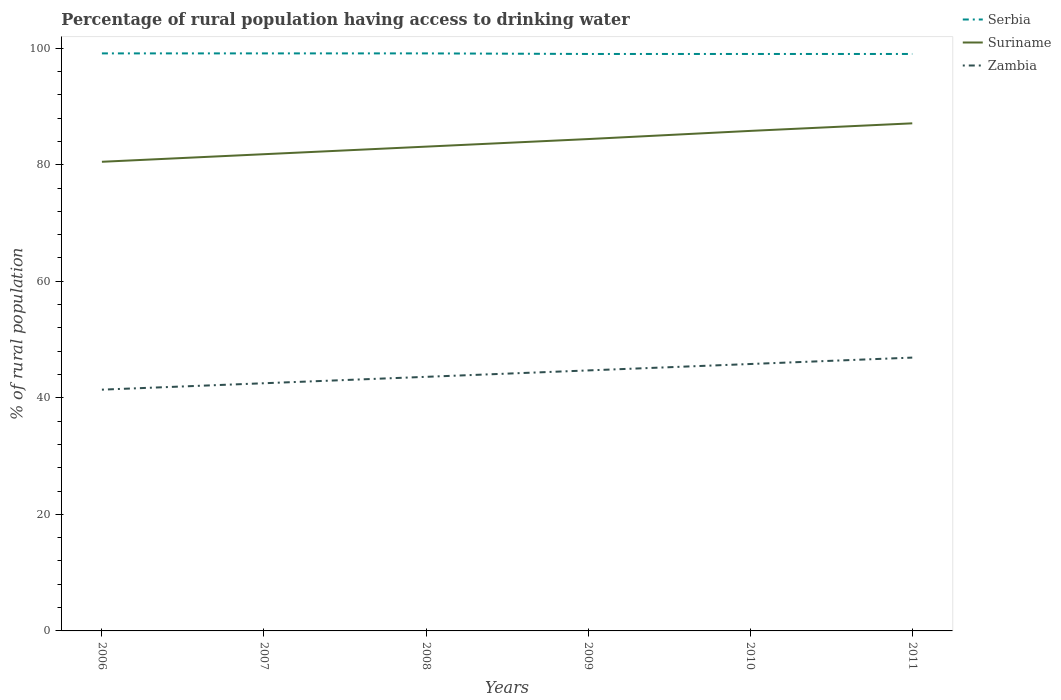Does the line corresponding to Zambia intersect with the line corresponding to Serbia?
Provide a short and direct response. No. Across all years, what is the maximum percentage of rural population having access to drinking water in Serbia?
Provide a succinct answer. 99. What is the total percentage of rural population having access to drinking water in Serbia in the graph?
Provide a succinct answer. 0.1. What is the difference between the highest and the second highest percentage of rural population having access to drinking water in Serbia?
Your response must be concise. 0.1. Is the percentage of rural population having access to drinking water in Zambia strictly greater than the percentage of rural population having access to drinking water in Suriname over the years?
Make the answer very short. Yes. How many lines are there?
Provide a short and direct response. 3. How many years are there in the graph?
Offer a very short reply. 6. Does the graph contain any zero values?
Ensure brevity in your answer.  No. Does the graph contain grids?
Provide a short and direct response. No. How many legend labels are there?
Ensure brevity in your answer.  3. What is the title of the graph?
Ensure brevity in your answer.  Percentage of rural population having access to drinking water. What is the label or title of the X-axis?
Keep it short and to the point. Years. What is the label or title of the Y-axis?
Provide a short and direct response. % of rural population. What is the % of rural population of Serbia in 2006?
Offer a terse response. 99.1. What is the % of rural population in Suriname in 2006?
Keep it short and to the point. 80.5. What is the % of rural population of Zambia in 2006?
Give a very brief answer. 41.4. What is the % of rural population of Serbia in 2007?
Make the answer very short. 99.1. What is the % of rural population of Suriname in 2007?
Offer a very short reply. 81.8. What is the % of rural population of Zambia in 2007?
Your response must be concise. 42.5. What is the % of rural population of Serbia in 2008?
Keep it short and to the point. 99.1. What is the % of rural population in Suriname in 2008?
Keep it short and to the point. 83.1. What is the % of rural population of Zambia in 2008?
Your response must be concise. 43.6. What is the % of rural population in Suriname in 2009?
Your answer should be very brief. 84.4. What is the % of rural population in Zambia in 2009?
Your answer should be very brief. 44.7. What is the % of rural population of Suriname in 2010?
Provide a succinct answer. 85.8. What is the % of rural population in Zambia in 2010?
Offer a very short reply. 45.8. What is the % of rural population of Suriname in 2011?
Your answer should be compact. 87.1. What is the % of rural population of Zambia in 2011?
Keep it short and to the point. 46.9. Across all years, what is the maximum % of rural population in Serbia?
Give a very brief answer. 99.1. Across all years, what is the maximum % of rural population in Suriname?
Your answer should be compact. 87.1. Across all years, what is the maximum % of rural population in Zambia?
Offer a terse response. 46.9. Across all years, what is the minimum % of rural population of Serbia?
Make the answer very short. 99. Across all years, what is the minimum % of rural population in Suriname?
Your answer should be compact. 80.5. Across all years, what is the minimum % of rural population in Zambia?
Your answer should be compact. 41.4. What is the total % of rural population of Serbia in the graph?
Ensure brevity in your answer.  594.3. What is the total % of rural population of Suriname in the graph?
Provide a succinct answer. 502.7. What is the total % of rural population of Zambia in the graph?
Ensure brevity in your answer.  264.9. What is the difference between the % of rural population in Serbia in 2006 and that in 2007?
Offer a very short reply. 0. What is the difference between the % of rural population in Suriname in 2006 and that in 2007?
Provide a succinct answer. -1.3. What is the difference between the % of rural population in Suriname in 2006 and that in 2008?
Provide a succinct answer. -2.6. What is the difference between the % of rural population of Zambia in 2006 and that in 2008?
Give a very brief answer. -2.2. What is the difference between the % of rural population of Suriname in 2006 and that in 2009?
Make the answer very short. -3.9. What is the difference between the % of rural population of Zambia in 2006 and that in 2009?
Your answer should be very brief. -3.3. What is the difference between the % of rural population of Serbia in 2006 and that in 2010?
Ensure brevity in your answer.  0.1. What is the difference between the % of rural population in Suriname in 2006 and that in 2011?
Make the answer very short. -6.6. What is the difference between the % of rural population in Zambia in 2006 and that in 2011?
Offer a very short reply. -5.5. What is the difference between the % of rural population of Zambia in 2007 and that in 2008?
Provide a succinct answer. -1.1. What is the difference between the % of rural population in Suriname in 2007 and that in 2009?
Your answer should be compact. -2.6. What is the difference between the % of rural population of Zambia in 2007 and that in 2009?
Your response must be concise. -2.2. What is the difference between the % of rural population in Zambia in 2007 and that in 2010?
Provide a short and direct response. -3.3. What is the difference between the % of rural population in Suriname in 2007 and that in 2011?
Provide a short and direct response. -5.3. What is the difference between the % of rural population in Zambia in 2008 and that in 2009?
Provide a succinct answer. -1.1. What is the difference between the % of rural population of Zambia in 2008 and that in 2010?
Your answer should be very brief. -2.2. What is the difference between the % of rural population of Suriname in 2008 and that in 2011?
Your answer should be compact. -4. What is the difference between the % of rural population of Serbia in 2009 and that in 2010?
Your response must be concise. 0. What is the difference between the % of rural population in Suriname in 2009 and that in 2010?
Offer a terse response. -1.4. What is the difference between the % of rural population of Serbia in 2009 and that in 2011?
Offer a very short reply. 0. What is the difference between the % of rural population of Suriname in 2009 and that in 2011?
Your response must be concise. -2.7. What is the difference between the % of rural population in Suriname in 2010 and that in 2011?
Keep it short and to the point. -1.3. What is the difference between the % of rural population of Serbia in 2006 and the % of rural population of Suriname in 2007?
Ensure brevity in your answer.  17.3. What is the difference between the % of rural population in Serbia in 2006 and the % of rural population in Zambia in 2007?
Your answer should be very brief. 56.6. What is the difference between the % of rural population of Suriname in 2006 and the % of rural population of Zambia in 2007?
Give a very brief answer. 38. What is the difference between the % of rural population of Serbia in 2006 and the % of rural population of Zambia in 2008?
Your answer should be compact. 55.5. What is the difference between the % of rural population of Suriname in 2006 and the % of rural population of Zambia in 2008?
Make the answer very short. 36.9. What is the difference between the % of rural population in Serbia in 2006 and the % of rural population in Suriname in 2009?
Your answer should be compact. 14.7. What is the difference between the % of rural population of Serbia in 2006 and the % of rural population of Zambia in 2009?
Provide a succinct answer. 54.4. What is the difference between the % of rural population of Suriname in 2006 and the % of rural population of Zambia in 2009?
Give a very brief answer. 35.8. What is the difference between the % of rural population in Serbia in 2006 and the % of rural population in Zambia in 2010?
Make the answer very short. 53.3. What is the difference between the % of rural population in Suriname in 2006 and the % of rural population in Zambia in 2010?
Your answer should be compact. 34.7. What is the difference between the % of rural population in Serbia in 2006 and the % of rural population in Zambia in 2011?
Your answer should be compact. 52.2. What is the difference between the % of rural population of Suriname in 2006 and the % of rural population of Zambia in 2011?
Give a very brief answer. 33.6. What is the difference between the % of rural population in Serbia in 2007 and the % of rural population in Suriname in 2008?
Provide a succinct answer. 16. What is the difference between the % of rural population in Serbia in 2007 and the % of rural population in Zambia in 2008?
Your answer should be compact. 55.5. What is the difference between the % of rural population of Suriname in 2007 and the % of rural population of Zambia in 2008?
Give a very brief answer. 38.2. What is the difference between the % of rural population in Serbia in 2007 and the % of rural population in Zambia in 2009?
Make the answer very short. 54.4. What is the difference between the % of rural population of Suriname in 2007 and the % of rural population of Zambia in 2009?
Provide a succinct answer. 37.1. What is the difference between the % of rural population of Serbia in 2007 and the % of rural population of Zambia in 2010?
Provide a succinct answer. 53.3. What is the difference between the % of rural population in Serbia in 2007 and the % of rural population in Suriname in 2011?
Offer a terse response. 12. What is the difference between the % of rural population in Serbia in 2007 and the % of rural population in Zambia in 2011?
Your response must be concise. 52.2. What is the difference between the % of rural population of Suriname in 2007 and the % of rural population of Zambia in 2011?
Offer a very short reply. 34.9. What is the difference between the % of rural population in Serbia in 2008 and the % of rural population in Suriname in 2009?
Provide a short and direct response. 14.7. What is the difference between the % of rural population of Serbia in 2008 and the % of rural population of Zambia in 2009?
Provide a succinct answer. 54.4. What is the difference between the % of rural population of Suriname in 2008 and the % of rural population of Zambia in 2009?
Provide a short and direct response. 38.4. What is the difference between the % of rural population of Serbia in 2008 and the % of rural population of Zambia in 2010?
Make the answer very short. 53.3. What is the difference between the % of rural population of Suriname in 2008 and the % of rural population of Zambia in 2010?
Give a very brief answer. 37.3. What is the difference between the % of rural population of Serbia in 2008 and the % of rural population of Zambia in 2011?
Offer a terse response. 52.2. What is the difference between the % of rural population of Suriname in 2008 and the % of rural population of Zambia in 2011?
Give a very brief answer. 36.2. What is the difference between the % of rural population of Serbia in 2009 and the % of rural population of Zambia in 2010?
Your response must be concise. 53.2. What is the difference between the % of rural population of Suriname in 2009 and the % of rural population of Zambia in 2010?
Provide a short and direct response. 38.6. What is the difference between the % of rural population in Serbia in 2009 and the % of rural population in Zambia in 2011?
Keep it short and to the point. 52.1. What is the difference between the % of rural population of Suriname in 2009 and the % of rural population of Zambia in 2011?
Make the answer very short. 37.5. What is the difference between the % of rural population of Serbia in 2010 and the % of rural population of Zambia in 2011?
Your answer should be very brief. 52.1. What is the difference between the % of rural population in Suriname in 2010 and the % of rural population in Zambia in 2011?
Keep it short and to the point. 38.9. What is the average % of rural population in Serbia per year?
Your response must be concise. 99.05. What is the average % of rural population of Suriname per year?
Make the answer very short. 83.78. What is the average % of rural population in Zambia per year?
Provide a short and direct response. 44.15. In the year 2006, what is the difference between the % of rural population of Serbia and % of rural population of Zambia?
Give a very brief answer. 57.7. In the year 2006, what is the difference between the % of rural population in Suriname and % of rural population in Zambia?
Keep it short and to the point. 39.1. In the year 2007, what is the difference between the % of rural population in Serbia and % of rural population in Suriname?
Ensure brevity in your answer.  17.3. In the year 2007, what is the difference between the % of rural population in Serbia and % of rural population in Zambia?
Your response must be concise. 56.6. In the year 2007, what is the difference between the % of rural population in Suriname and % of rural population in Zambia?
Your response must be concise. 39.3. In the year 2008, what is the difference between the % of rural population of Serbia and % of rural population of Suriname?
Keep it short and to the point. 16. In the year 2008, what is the difference between the % of rural population of Serbia and % of rural population of Zambia?
Give a very brief answer. 55.5. In the year 2008, what is the difference between the % of rural population in Suriname and % of rural population in Zambia?
Your answer should be compact. 39.5. In the year 2009, what is the difference between the % of rural population of Serbia and % of rural population of Suriname?
Offer a very short reply. 14.6. In the year 2009, what is the difference between the % of rural population in Serbia and % of rural population in Zambia?
Keep it short and to the point. 54.3. In the year 2009, what is the difference between the % of rural population in Suriname and % of rural population in Zambia?
Ensure brevity in your answer.  39.7. In the year 2010, what is the difference between the % of rural population in Serbia and % of rural population in Zambia?
Keep it short and to the point. 53.2. In the year 2010, what is the difference between the % of rural population in Suriname and % of rural population in Zambia?
Your response must be concise. 40. In the year 2011, what is the difference between the % of rural population in Serbia and % of rural population in Zambia?
Offer a terse response. 52.1. In the year 2011, what is the difference between the % of rural population in Suriname and % of rural population in Zambia?
Provide a short and direct response. 40.2. What is the ratio of the % of rural population in Suriname in 2006 to that in 2007?
Offer a very short reply. 0.98. What is the ratio of the % of rural population of Zambia in 2006 to that in 2007?
Keep it short and to the point. 0.97. What is the ratio of the % of rural population of Suriname in 2006 to that in 2008?
Your answer should be compact. 0.97. What is the ratio of the % of rural population of Zambia in 2006 to that in 2008?
Provide a succinct answer. 0.95. What is the ratio of the % of rural population of Suriname in 2006 to that in 2009?
Your response must be concise. 0.95. What is the ratio of the % of rural population in Zambia in 2006 to that in 2009?
Your answer should be very brief. 0.93. What is the ratio of the % of rural population of Suriname in 2006 to that in 2010?
Offer a terse response. 0.94. What is the ratio of the % of rural population in Zambia in 2006 to that in 2010?
Offer a very short reply. 0.9. What is the ratio of the % of rural population of Serbia in 2006 to that in 2011?
Make the answer very short. 1. What is the ratio of the % of rural population of Suriname in 2006 to that in 2011?
Offer a terse response. 0.92. What is the ratio of the % of rural population in Zambia in 2006 to that in 2011?
Your answer should be compact. 0.88. What is the ratio of the % of rural population of Serbia in 2007 to that in 2008?
Your response must be concise. 1. What is the ratio of the % of rural population in Suriname in 2007 to that in 2008?
Your answer should be compact. 0.98. What is the ratio of the % of rural population in Zambia in 2007 to that in 2008?
Your response must be concise. 0.97. What is the ratio of the % of rural population of Serbia in 2007 to that in 2009?
Your answer should be compact. 1. What is the ratio of the % of rural population of Suriname in 2007 to that in 2009?
Offer a terse response. 0.97. What is the ratio of the % of rural population of Zambia in 2007 to that in 2009?
Make the answer very short. 0.95. What is the ratio of the % of rural population of Suriname in 2007 to that in 2010?
Your response must be concise. 0.95. What is the ratio of the % of rural population in Zambia in 2007 to that in 2010?
Give a very brief answer. 0.93. What is the ratio of the % of rural population in Serbia in 2007 to that in 2011?
Offer a very short reply. 1. What is the ratio of the % of rural population of Suriname in 2007 to that in 2011?
Give a very brief answer. 0.94. What is the ratio of the % of rural population of Zambia in 2007 to that in 2011?
Your response must be concise. 0.91. What is the ratio of the % of rural population in Serbia in 2008 to that in 2009?
Provide a short and direct response. 1. What is the ratio of the % of rural population of Suriname in 2008 to that in 2009?
Your answer should be compact. 0.98. What is the ratio of the % of rural population in Zambia in 2008 to that in 2009?
Ensure brevity in your answer.  0.98. What is the ratio of the % of rural population of Serbia in 2008 to that in 2010?
Ensure brevity in your answer.  1. What is the ratio of the % of rural population in Suriname in 2008 to that in 2010?
Your response must be concise. 0.97. What is the ratio of the % of rural population in Serbia in 2008 to that in 2011?
Ensure brevity in your answer.  1. What is the ratio of the % of rural population in Suriname in 2008 to that in 2011?
Keep it short and to the point. 0.95. What is the ratio of the % of rural population in Zambia in 2008 to that in 2011?
Offer a very short reply. 0.93. What is the ratio of the % of rural population of Serbia in 2009 to that in 2010?
Give a very brief answer. 1. What is the ratio of the % of rural population of Suriname in 2009 to that in 2010?
Your answer should be compact. 0.98. What is the ratio of the % of rural population in Zambia in 2009 to that in 2010?
Your answer should be very brief. 0.98. What is the ratio of the % of rural population in Serbia in 2009 to that in 2011?
Ensure brevity in your answer.  1. What is the ratio of the % of rural population of Suriname in 2009 to that in 2011?
Ensure brevity in your answer.  0.97. What is the ratio of the % of rural population of Zambia in 2009 to that in 2011?
Provide a succinct answer. 0.95. What is the ratio of the % of rural population of Serbia in 2010 to that in 2011?
Provide a succinct answer. 1. What is the ratio of the % of rural population in Suriname in 2010 to that in 2011?
Ensure brevity in your answer.  0.99. What is the ratio of the % of rural population of Zambia in 2010 to that in 2011?
Make the answer very short. 0.98. What is the difference between the highest and the second highest % of rural population in Serbia?
Offer a terse response. 0. What is the difference between the highest and the second highest % of rural population of Zambia?
Give a very brief answer. 1.1. What is the difference between the highest and the lowest % of rural population of Serbia?
Keep it short and to the point. 0.1. What is the difference between the highest and the lowest % of rural population in Zambia?
Offer a terse response. 5.5. 